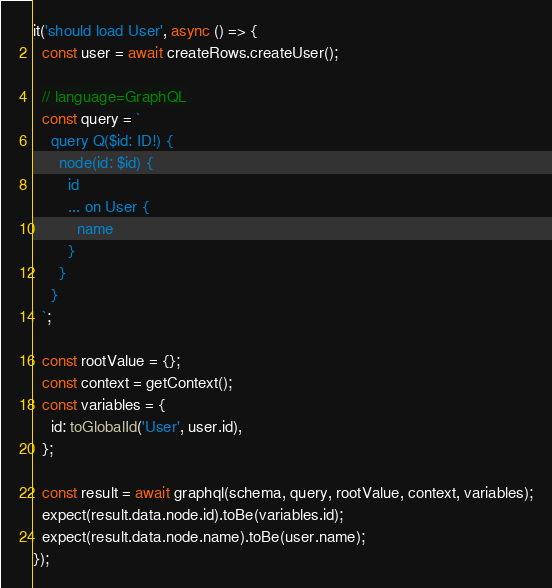<code> <loc_0><loc_0><loc_500><loc_500><_TypeScript_>
it('should load User', async () => {
  const user = await createRows.createUser();

  // language=GraphQL
  const query = `
    query Q($id: ID!) {
      node(id: $id) {
        id
        ... on User {
          name
        }
      }
    }
  `;

  const rootValue = {};
  const context = getContext();
  const variables = {
    id: toGlobalId('User', user.id),
  };

  const result = await graphql(schema, query, rootValue, context, variables);
  expect(result.data.node.id).toBe(variables.id);
  expect(result.data.node.name).toBe(user.name);
});
</code> 